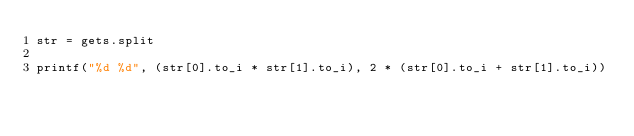<code> <loc_0><loc_0><loc_500><loc_500><_Ruby_>str = gets.split

printf("%d %d", (str[0].to_i * str[1].to_i), 2 * (str[0].to_i + str[1].to_i))

</code> 